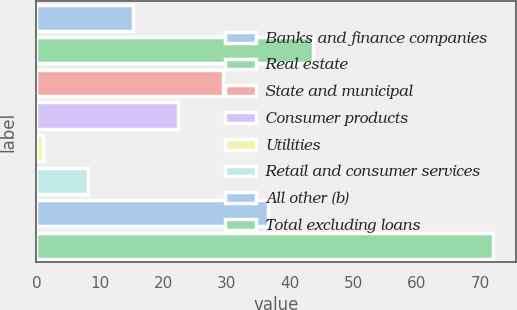Convert chart to OTSL. <chart><loc_0><loc_0><loc_500><loc_500><bar_chart><fcel>Banks and finance companies<fcel>Real estate<fcel>State and municipal<fcel>Consumer products<fcel>Utilities<fcel>Retail and consumer services<fcel>All other (b)<fcel>Total excluding loans<nl><fcel>15.2<fcel>43.6<fcel>29.4<fcel>22.3<fcel>1<fcel>8.1<fcel>36.5<fcel>72<nl></chart> 